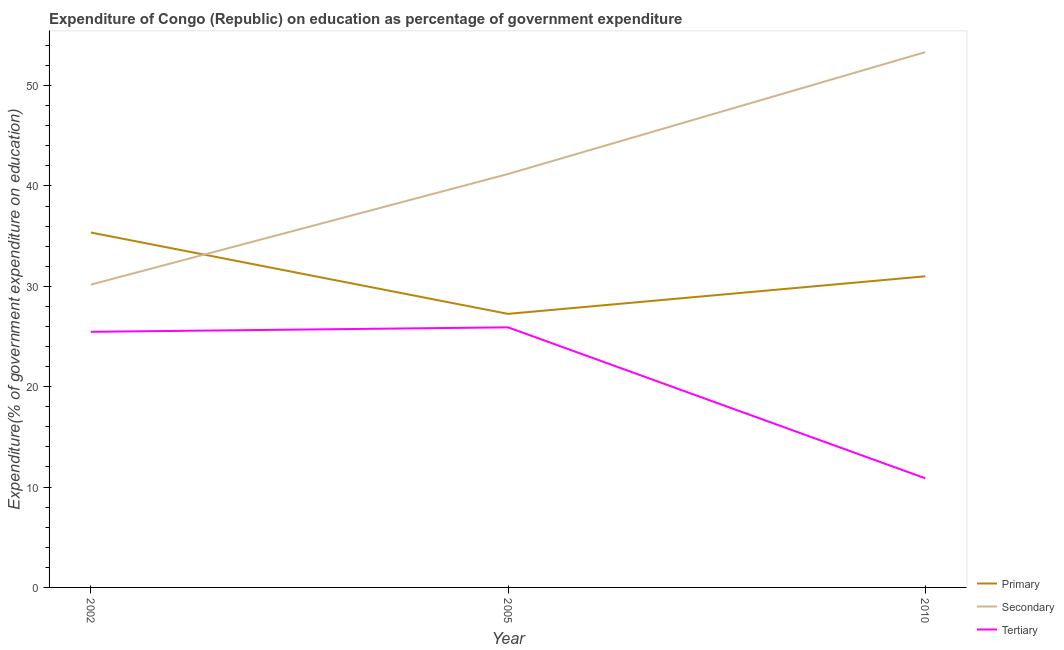What is the expenditure on tertiary education in 2002?
Offer a terse response. 25.47. Across all years, what is the maximum expenditure on tertiary education?
Provide a short and direct response. 25.91. Across all years, what is the minimum expenditure on secondary education?
Make the answer very short. 30.17. In which year was the expenditure on secondary education minimum?
Ensure brevity in your answer.  2002. What is the total expenditure on tertiary education in the graph?
Ensure brevity in your answer.  62.25. What is the difference between the expenditure on secondary education in 2005 and that in 2010?
Your answer should be very brief. -12.14. What is the difference between the expenditure on tertiary education in 2005 and the expenditure on primary education in 2002?
Keep it short and to the point. -9.45. What is the average expenditure on secondary education per year?
Your answer should be very brief. 41.56. In the year 2005, what is the difference between the expenditure on tertiary education and expenditure on primary education?
Make the answer very short. -1.34. In how many years, is the expenditure on tertiary education greater than 30 %?
Keep it short and to the point. 0. What is the ratio of the expenditure on tertiary education in 2002 to that in 2005?
Offer a very short reply. 0.98. Is the expenditure on tertiary education in 2002 less than that in 2005?
Provide a short and direct response. Yes. Is the difference between the expenditure on secondary education in 2002 and 2005 greater than the difference between the expenditure on tertiary education in 2002 and 2005?
Your answer should be very brief. No. What is the difference between the highest and the second highest expenditure on tertiary education?
Make the answer very short. 0.45. What is the difference between the highest and the lowest expenditure on tertiary education?
Make the answer very short. 15.04. In how many years, is the expenditure on primary education greater than the average expenditure on primary education taken over all years?
Your answer should be compact. 1. Does the expenditure on secondary education monotonically increase over the years?
Your answer should be very brief. Yes. Is the expenditure on tertiary education strictly greater than the expenditure on primary education over the years?
Provide a succinct answer. No. How many years are there in the graph?
Provide a succinct answer. 3. Does the graph contain any zero values?
Ensure brevity in your answer.  No. Where does the legend appear in the graph?
Provide a short and direct response. Bottom right. What is the title of the graph?
Your response must be concise. Expenditure of Congo (Republic) on education as percentage of government expenditure. What is the label or title of the X-axis?
Offer a very short reply. Year. What is the label or title of the Y-axis?
Keep it short and to the point. Expenditure(% of government expenditure on education). What is the Expenditure(% of government expenditure on education) of Primary in 2002?
Your answer should be very brief. 35.36. What is the Expenditure(% of government expenditure on education) in Secondary in 2002?
Make the answer very short. 30.17. What is the Expenditure(% of government expenditure on education) of Tertiary in 2002?
Your response must be concise. 25.47. What is the Expenditure(% of government expenditure on education) in Primary in 2005?
Ensure brevity in your answer.  27.25. What is the Expenditure(% of government expenditure on education) in Secondary in 2005?
Provide a short and direct response. 41.19. What is the Expenditure(% of government expenditure on education) of Tertiary in 2005?
Provide a succinct answer. 25.91. What is the Expenditure(% of government expenditure on education) of Primary in 2010?
Make the answer very short. 31. What is the Expenditure(% of government expenditure on education) of Secondary in 2010?
Ensure brevity in your answer.  53.33. What is the Expenditure(% of government expenditure on education) of Tertiary in 2010?
Make the answer very short. 10.87. Across all years, what is the maximum Expenditure(% of government expenditure on education) in Primary?
Provide a short and direct response. 35.36. Across all years, what is the maximum Expenditure(% of government expenditure on education) of Secondary?
Your answer should be very brief. 53.33. Across all years, what is the maximum Expenditure(% of government expenditure on education) in Tertiary?
Ensure brevity in your answer.  25.91. Across all years, what is the minimum Expenditure(% of government expenditure on education) in Primary?
Offer a very short reply. 27.25. Across all years, what is the minimum Expenditure(% of government expenditure on education) in Secondary?
Make the answer very short. 30.17. Across all years, what is the minimum Expenditure(% of government expenditure on education) of Tertiary?
Your answer should be very brief. 10.87. What is the total Expenditure(% of government expenditure on education) in Primary in the graph?
Give a very brief answer. 93.61. What is the total Expenditure(% of government expenditure on education) in Secondary in the graph?
Provide a succinct answer. 124.69. What is the total Expenditure(% of government expenditure on education) of Tertiary in the graph?
Ensure brevity in your answer.  62.25. What is the difference between the Expenditure(% of government expenditure on education) in Primary in 2002 and that in 2005?
Your answer should be compact. 8.11. What is the difference between the Expenditure(% of government expenditure on education) in Secondary in 2002 and that in 2005?
Keep it short and to the point. -11.02. What is the difference between the Expenditure(% of government expenditure on education) of Tertiary in 2002 and that in 2005?
Your response must be concise. -0.45. What is the difference between the Expenditure(% of government expenditure on education) of Primary in 2002 and that in 2010?
Give a very brief answer. 4.36. What is the difference between the Expenditure(% of government expenditure on education) in Secondary in 2002 and that in 2010?
Offer a very short reply. -23.16. What is the difference between the Expenditure(% of government expenditure on education) in Tertiary in 2002 and that in 2010?
Offer a very short reply. 14.59. What is the difference between the Expenditure(% of government expenditure on education) in Primary in 2005 and that in 2010?
Provide a short and direct response. -3.74. What is the difference between the Expenditure(% of government expenditure on education) in Secondary in 2005 and that in 2010?
Your response must be concise. -12.14. What is the difference between the Expenditure(% of government expenditure on education) in Tertiary in 2005 and that in 2010?
Your answer should be very brief. 15.04. What is the difference between the Expenditure(% of government expenditure on education) in Primary in 2002 and the Expenditure(% of government expenditure on education) in Secondary in 2005?
Keep it short and to the point. -5.83. What is the difference between the Expenditure(% of government expenditure on education) in Primary in 2002 and the Expenditure(% of government expenditure on education) in Tertiary in 2005?
Your response must be concise. 9.45. What is the difference between the Expenditure(% of government expenditure on education) in Secondary in 2002 and the Expenditure(% of government expenditure on education) in Tertiary in 2005?
Your answer should be compact. 4.26. What is the difference between the Expenditure(% of government expenditure on education) in Primary in 2002 and the Expenditure(% of government expenditure on education) in Secondary in 2010?
Your answer should be very brief. -17.97. What is the difference between the Expenditure(% of government expenditure on education) of Primary in 2002 and the Expenditure(% of government expenditure on education) of Tertiary in 2010?
Provide a short and direct response. 24.49. What is the difference between the Expenditure(% of government expenditure on education) of Secondary in 2002 and the Expenditure(% of government expenditure on education) of Tertiary in 2010?
Make the answer very short. 19.3. What is the difference between the Expenditure(% of government expenditure on education) of Primary in 2005 and the Expenditure(% of government expenditure on education) of Secondary in 2010?
Your answer should be very brief. -26.08. What is the difference between the Expenditure(% of government expenditure on education) of Primary in 2005 and the Expenditure(% of government expenditure on education) of Tertiary in 2010?
Provide a short and direct response. 16.38. What is the difference between the Expenditure(% of government expenditure on education) in Secondary in 2005 and the Expenditure(% of government expenditure on education) in Tertiary in 2010?
Ensure brevity in your answer.  30.32. What is the average Expenditure(% of government expenditure on education) of Primary per year?
Provide a short and direct response. 31.2. What is the average Expenditure(% of government expenditure on education) in Secondary per year?
Keep it short and to the point. 41.56. What is the average Expenditure(% of government expenditure on education) of Tertiary per year?
Provide a succinct answer. 20.75. In the year 2002, what is the difference between the Expenditure(% of government expenditure on education) in Primary and Expenditure(% of government expenditure on education) in Secondary?
Offer a terse response. 5.19. In the year 2002, what is the difference between the Expenditure(% of government expenditure on education) of Primary and Expenditure(% of government expenditure on education) of Tertiary?
Give a very brief answer. 9.89. In the year 2002, what is the difference between the Expenditure(% of government expenditure on education) of Secondary and Expenditure(% of government expenditure on education) of Tertiary?
Offer a very short reply. 4.7. In the year 2005, what is the difference between the Expenditure(% of government expenditure on education) of Primary and Expenditure(% of government expenditure on education) of Secondary?
Offer a very short reply. -13.94. In the year 2005, what is the difference between the Expenditure(% of government expenditure on education) of Primary and Expenditure(% of government expenditure on education) of Tertiary?
Offer a terse response. 1.34. In the year 2005, what is the difference between the Expenditure(% of government expenditure on education) in Secondary and Expenditure(% of government expenditure on education) in Tertiary?
Give a very brief answer. 15.28. In the year 2010, what is the difference between the Expenditure(% of government expenditure on education) of Primary and Expenditure(% of government expenditure on education) of Secondary?
Make the answer very short. -22.33. In the year 2010, what is the difference between the Expenditure(% of government expenditure on education) of Primary and Expenditure(% of government expenditure on education) of Tertiary?
Provide a short and direct response. 20.13. In the year 2010, what is the difference between the Expenditure(% of government expenditure on education) in Secondary and Expenditure(% of government expenditure on education) in Tertiary?
Provide a short and direct response. 42.46. What is the ratio of the Expenditure(% of government expenditure on education) of Primary in 2002 to that in 2005?
Keep it short and to the point. 1.3. What is the ratio of the Expenditure(% of government expenditure on education) in Secondary in 2002 to that in 2005?
Your answer should be compact. 0.73. What is the ratio of the Expenditure(% of government expenditure on education) in Tertiary in 2002 to that in 2005?
Make the answer very short. 0.98. What is the ratio of the Expenditure(% of government expenditure on education) of Primary in 2002 to that in 2010?
Offer a very short reply. 1.14. What is the ratio of the Expenditure(% of government expenditure on education) of Secondary in 2002 to that in 2010?
Make the answer very short. 0.57. What is the ratio of the Expenditure(% of government expenditure on education) in Tertiary in 2002 to that in 2010?
Offer a terse response. 2.34. What is the ratio of the Expenditure(% of government expenditure on education) in Primary in 2005 to that in 2010?
Make the answer very short. 0.88. What is the ratio of the Expenditure(% of government expenditure on education) of Secondary in 2005 to that in 2010?
Your response must be concise. 0.77. What is the ratio of the Expenditure(% of government expenditure on education) of Tertiary in 2005 to that in 2010?
Your answer should be very brief. 2.38. What is the difference between the highest and the second highest Expenditure(% of government expenditure on education) in Primary?
Offer a terse response. 4.36. What is the difference between the highest and the second highest Expenditure(% of government expenditure on education) in Secondary?
Provide a short and direct response. 12.14. What is the difference between the highest and the second highest Expenditure(% of government expenditure on education) in Tertiary?
Offer a terse response. 0.45. What is the difference between the highest and the lowest Expenditure(% of government expenditure on education) of Primary?
Provide a succinct answer. 8.11. What is the difference between the highest and the lowest Expenditure(% of government expenditure on education) in Secondary?
Your answer should be compact. 23.16. What is the difference between the highest and the lowest Expenditure(% of government expenditure on education) of Tertiary?
Keep it short and to the point. 15.04. 